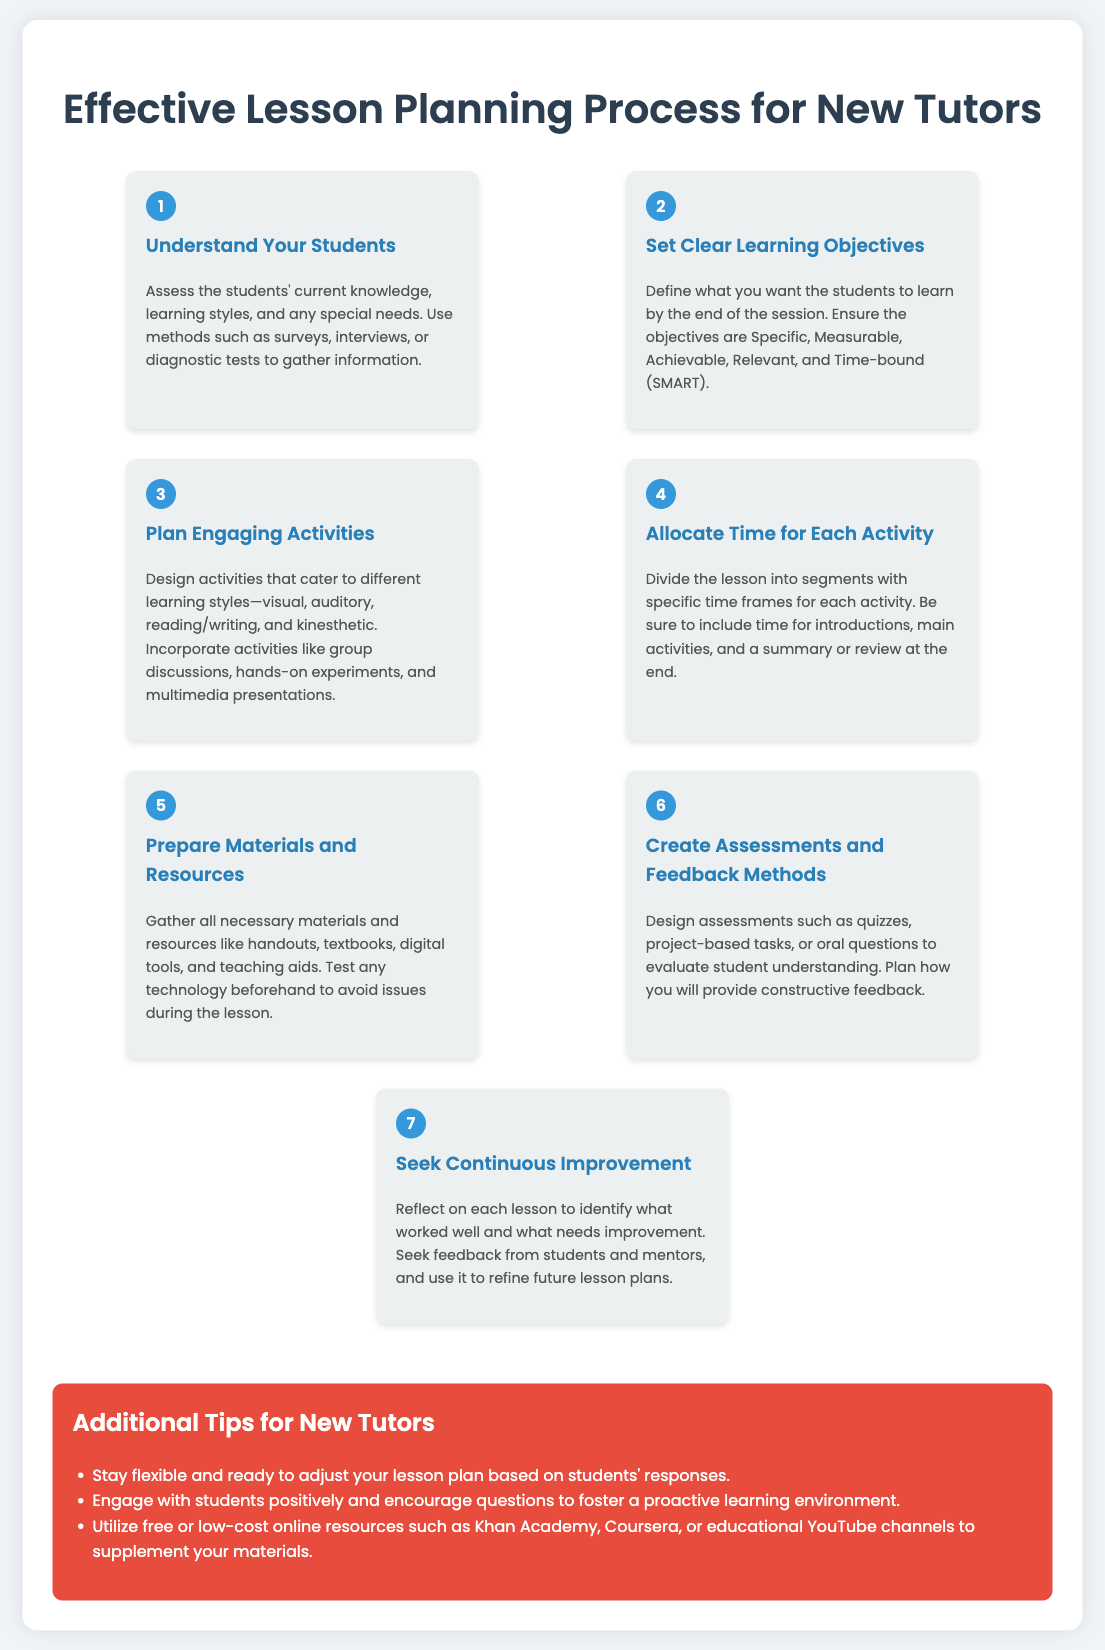What is the first step in the lesson planning process? The first step is to assess the students' current knowledge, learning styles, and any special needs.
Answer: Understand Your Students What does SMART stand for in setting learning objectives? SMART refers to the criteria used in defining clear learning objectives.
Answer: Specific, Measurable, Achievable, Relevant, Time-bound How many types of learning styles should activities cater to? The document mentions including activities for various types of learning preferences.
Answer: Four What should tutors reflect on after each lesson? Tutors should identify what worked well and what needs improvement.
Answer: Continuous Improvement What type of materials and resources should be prepared? Tutors should gather handouts, textbooks, digital tools, and teaching aids.
Answer: Necessary materials and resources What factor is suggested to be included in the lesson planning? Tutors are encouraged to adjust their lesson plan based on student feedback.
Answer: Flexibility How many steps are outlined in the effective lesson planning process? The document lists a series of distinct steps that comprise the planning process.
Answer: Seven What kind of assessments are to be designed? These assessments aim to evaluate student understanding.
Answer: Quizzes, project-based tasks, or oral questions What is one tip for new tutors regarding lesson adjustments? New tutors are advised to engage positively with students and be open to their questions.
Answer: Stay flexible 